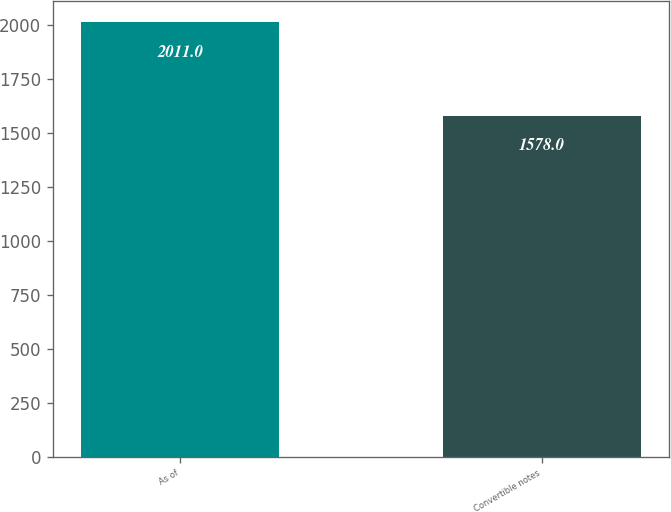Convert chart. <chart><loc_0><loc_0><loc_500><loc_500><bar_chart><fcel>As of<fcel>Convertible notes<nl><fcel>2011<fcel>1578<nl></chart> 